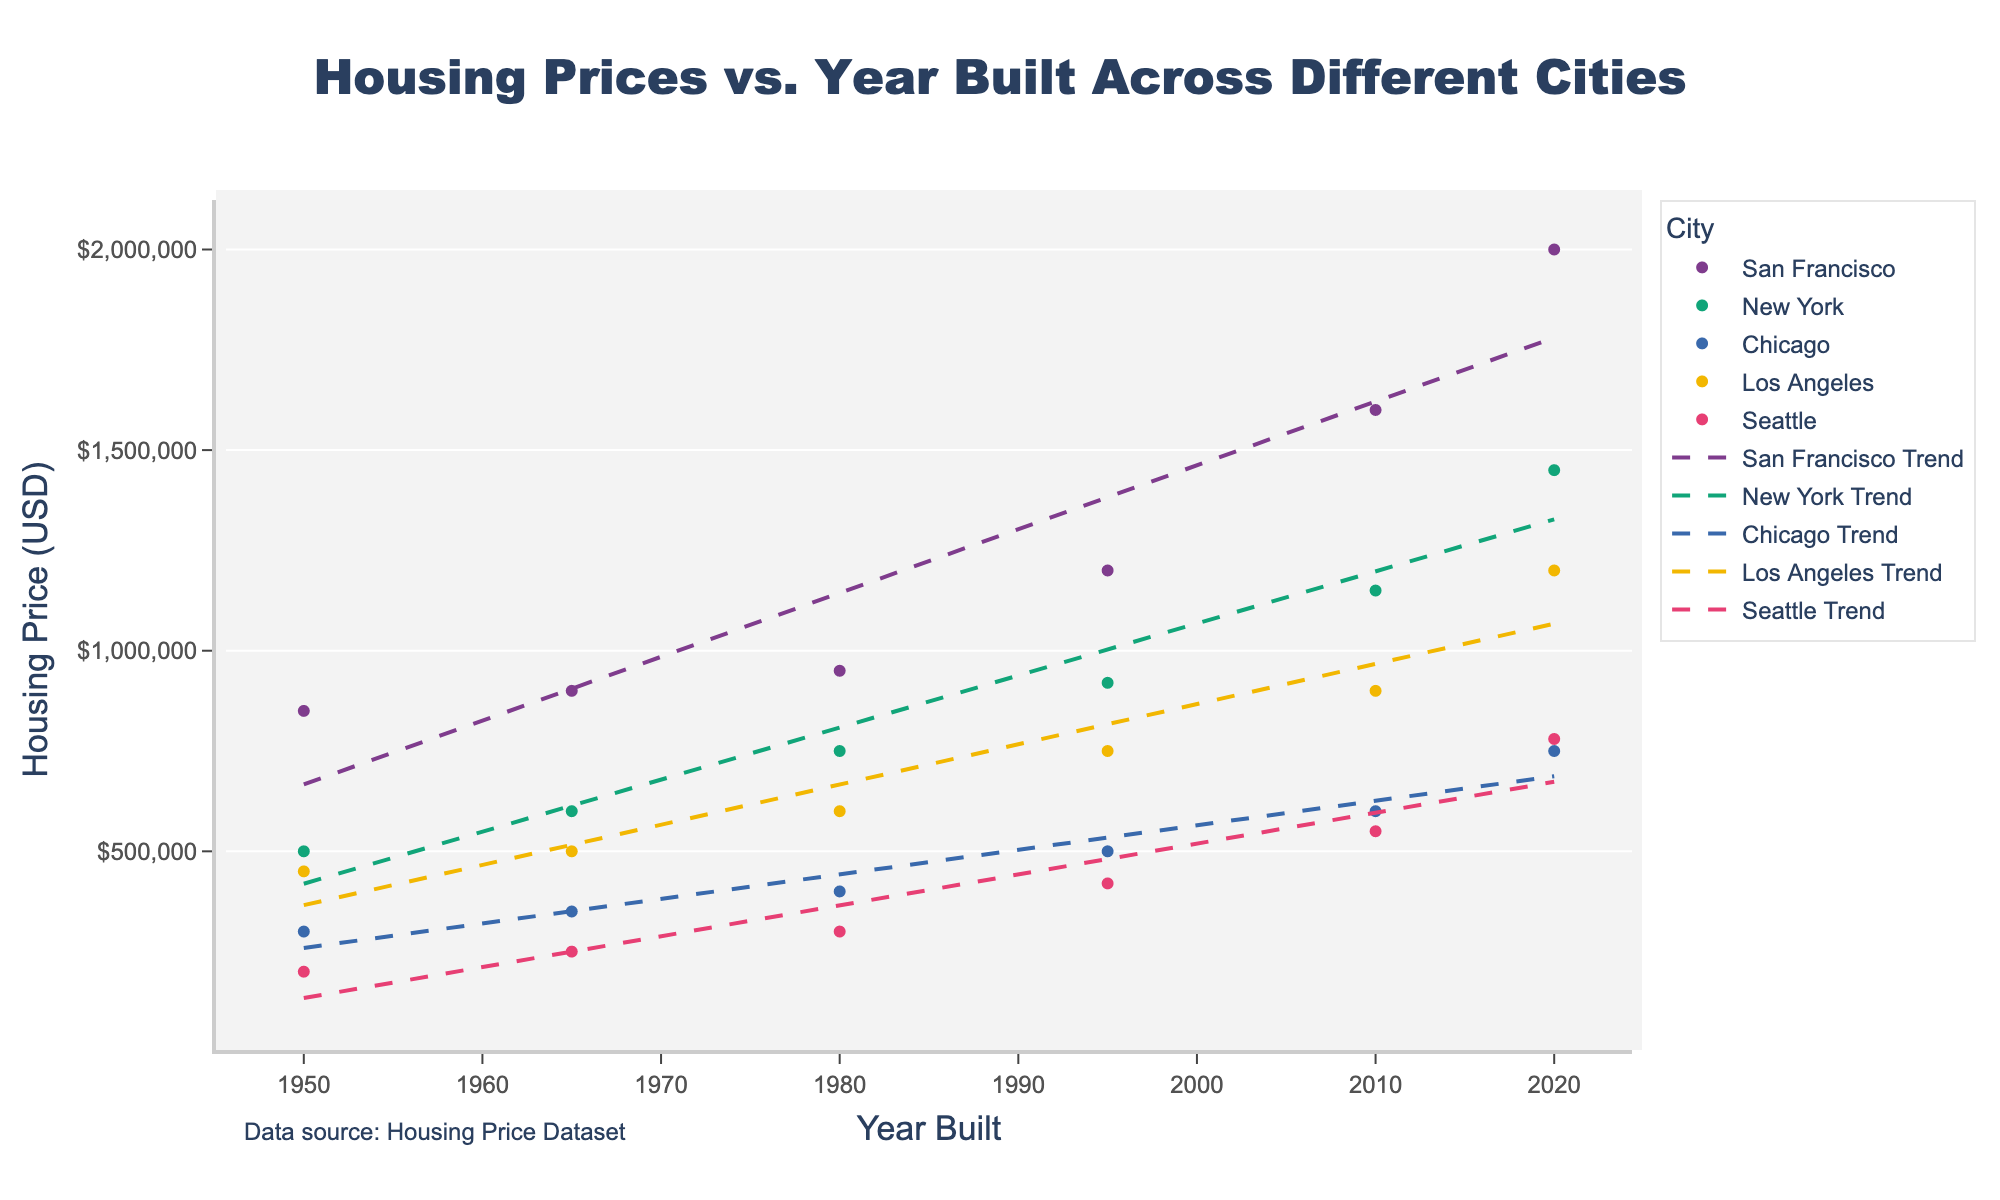What is the title of the scatter plot? The title is located at the top center of the figure. It reads "Housing Prices vs. Year Built Across Different Cities".
Answer: Housing Prices vs. Year Built Across Different Cities Which city had the highest housing price in 2020? By looking at the topmost data points on the figure, we can see that San Francisco had the highest housing price in 2020, reaching $2,000,000.
Answer: San Francisco How does the trend line for Seattle compare to the trend line for Chicago? The trend lines for Seattle and Chicago both have a positive slope, indicating an increase in housing prices over the years. However, the slope for Seattle is steeper, suggesting a faster increase in housing prices compared to Chicago.
Answer: Seattle's trend line has a steeper slope What was the approximate housing price in Los Angeles in 1995? Locate the data point for Los Angeles at 1995 on the x-axis. The corresponding y-value shows a housing price of approximately $750,000.
Answer: $750,000 Which city had the most significant increase in housing prices from 1980 to 2020? To find the city with the most significant increase, compare the end points for 1980 and 2020 in each city. San Francisco's housing price increased from $950,000 in 1980 to $2,000,000 in 2020, the largest increase among the cities.
Answer: San Francisco Between New York and Los Angeles, which city had higher housing prices in 2010? Look at the data points for both cities in 2010 on the x-axis. New York had a housing price of $1,150,000, whereas Los Angeles had $900,000.
Answer: New York What is the overall trend for housing prices across the different cities from 1950 to 2020? By observing the trend lines for all cities, we see that all trend lines show a positive slope, indicating that housing prices have generally increased over the years for all cities.
Answer: Generally increasing How much did the housing price in San Francisco increase between 1995 and 2010? Locate the data points for San Francisco in 1995 and 2010, then find the difference between the housing prices: $1,600,000 - $1,200,000 = $400,000.
Answer: $400,000 Which city had the slowest growth in housing prices over the years? By comparing the slopes of the trend lines, we notice that Chicago's trend line is the flattest, indicating the slowest growth in housing prices.
Answer: Chicago 